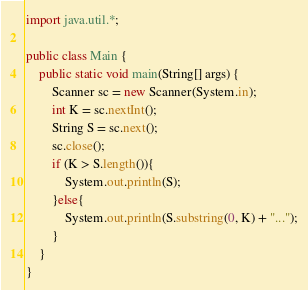Convert code to text. <code><loc_0><loc_0><loc_500><loc_500><_Java_>import java.util.*;

public class Main {
    public static void main(String[] args) {
        Scanner sc = new Scanner(System.in);
		int K = sc.nextInt();
		String S = sc.next();
		sc.close();
		if (K > S.length()){
			System.out.println(S);
		}else{
			System.out.println(S.substring(0, K) + "...");
		}
    }
}</code> 